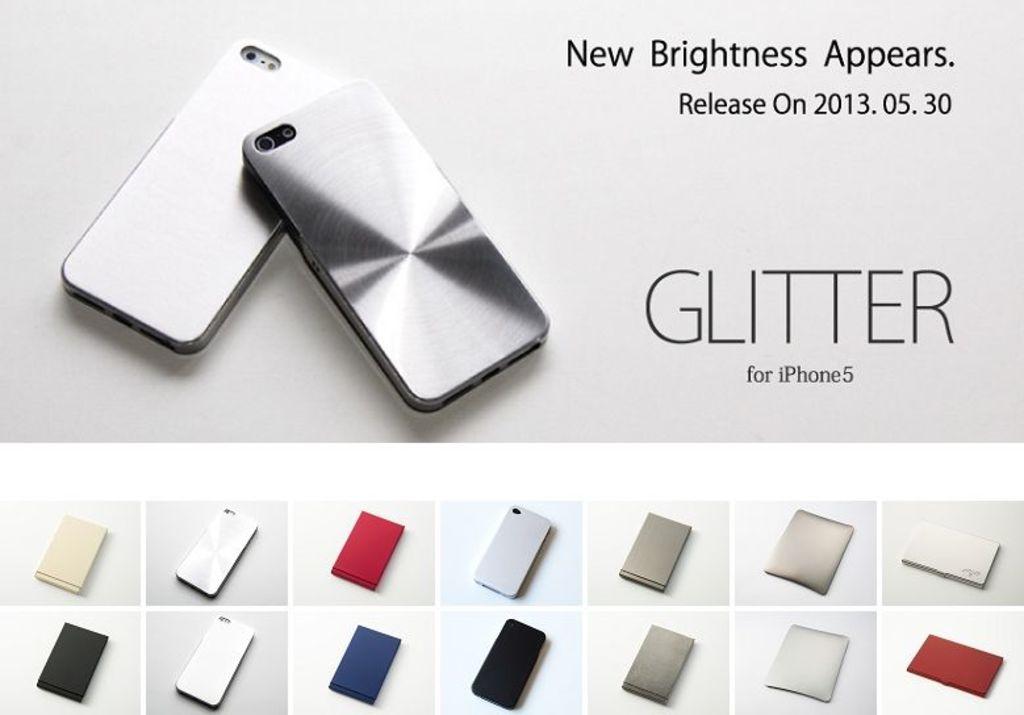What is the release date?
Your answer should be very brief. 2013.05.30. What is new about this?
Make the answer very short. Brightness. 